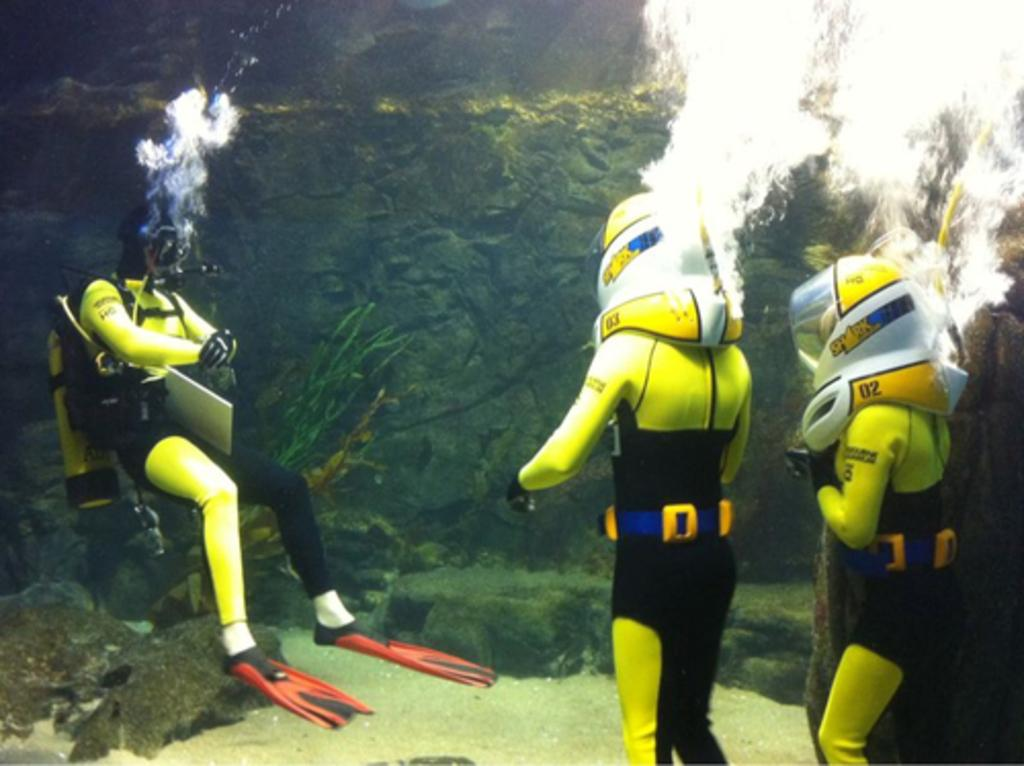<image>
Present a compact description of the photo's key features. Some people are underwater wearing breathing helmets labelled 02 & 03. 